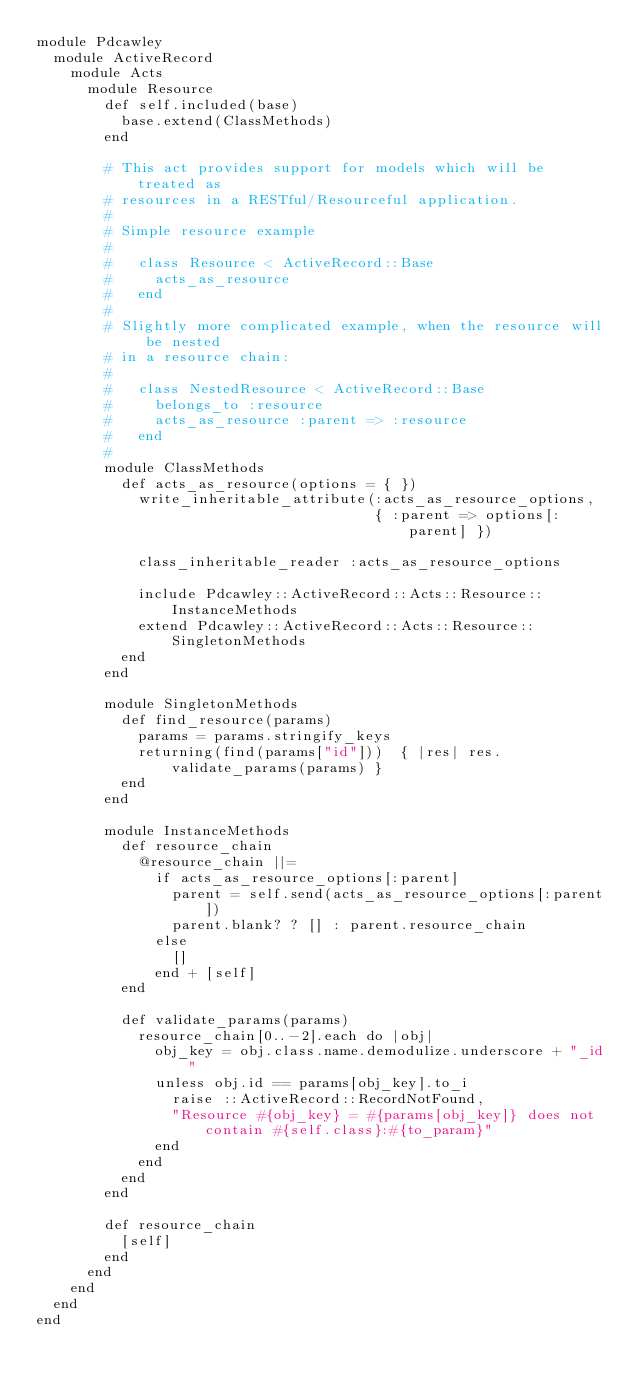<code> <loc_0><loc_0><loc_500><loc_500><_Ruby_>module Pdcawley
  module ActiveRecord
    module Acts
      module Resource
        def self.included(base)
          base.extend(ClassMethods)
        end

        # This act provides support for models which will be treated as
        # resources in a RESTful/Resourceful application.
        #
        # Simple resource example
        #
        #   class Resource < ActiveRecord::Base
        #     acts_as_resource
        #   end
        #
        # Slightly more complicated example, when the resource will be nested
        # in a resource chain:
        #
        #   class NestedResource < ActiveRecord::Base
        #     belongs_to :resource
        #     acts_as_resource :parent => :resource
        #   end
        #
        module ClassMethods
          def acts_as_resource(options = { })
            write_inheritable_attribute(:acts_as_resource_options,
                                        { :parent => options[:parent] })

            class_inheritable_reader :acts_as_resource_options

            include Pdcawley::ActiveRecord::Acts::Resource::InstanceMethods
            extend Pdcawley::ActiveRecord::Acts::Resource::SingletonMethods
          end
        end

        module SingletonMethods
          def find_resource(params)
            params = params.stringify_keys
            returning(find(params["id"]))  { |res| res.validate_params(params) }
          end
        end

        module InstanceMethods
          def resource_chain
            @resource_chain ||=
              if acts_as_resource_options[:parent]
                parent = self.send(acts_as_resource_options[:parent])
                parent.blank? ? [] : parent.resource_chain
              else
                []
              end + [self]
          end

          def validate_params(params)
            resource_chain[0..-2].each do |obj|
              obj_key = obj.class.name.demodulize.underscore + "_id"
              unless obj.id == params[obj_key].to_i
                raise ::ActiveRecord::RecordNotFound,
                "Resource #{obj_key} = #{params[obj_key]} does not contain #{self.class}:#{to_param}"
              end
            end
          end
        end

        def resource_chain
          [self]
        end
      end
    end
  end
end
</code> 